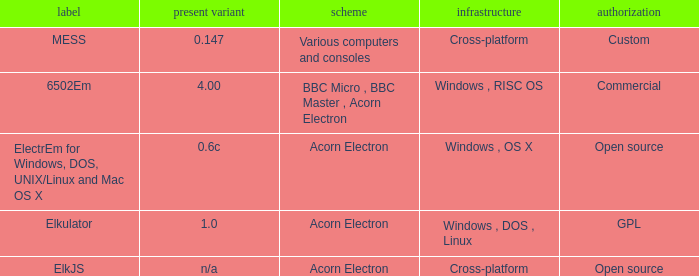Which system is named ELKJS? Acorn Electron. 